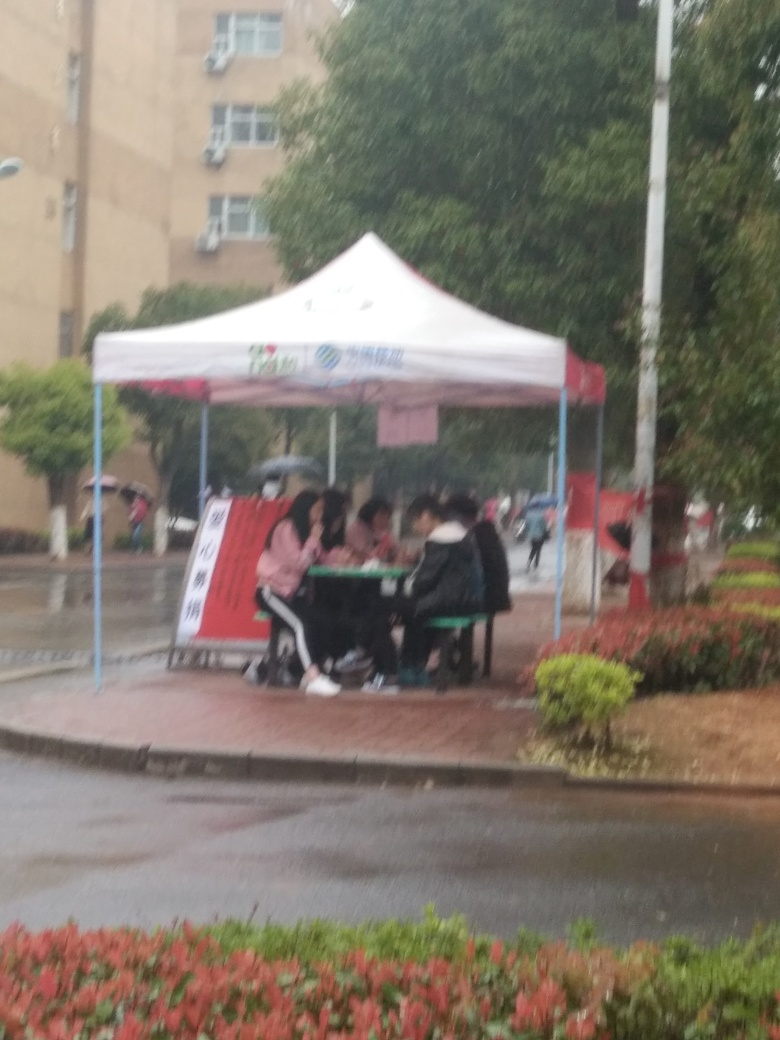What is the weather like in the image? The weather appears to be rainy or just after a rain shower, given the wet surfaces and the fact that individuals are gathered under a shelter. 